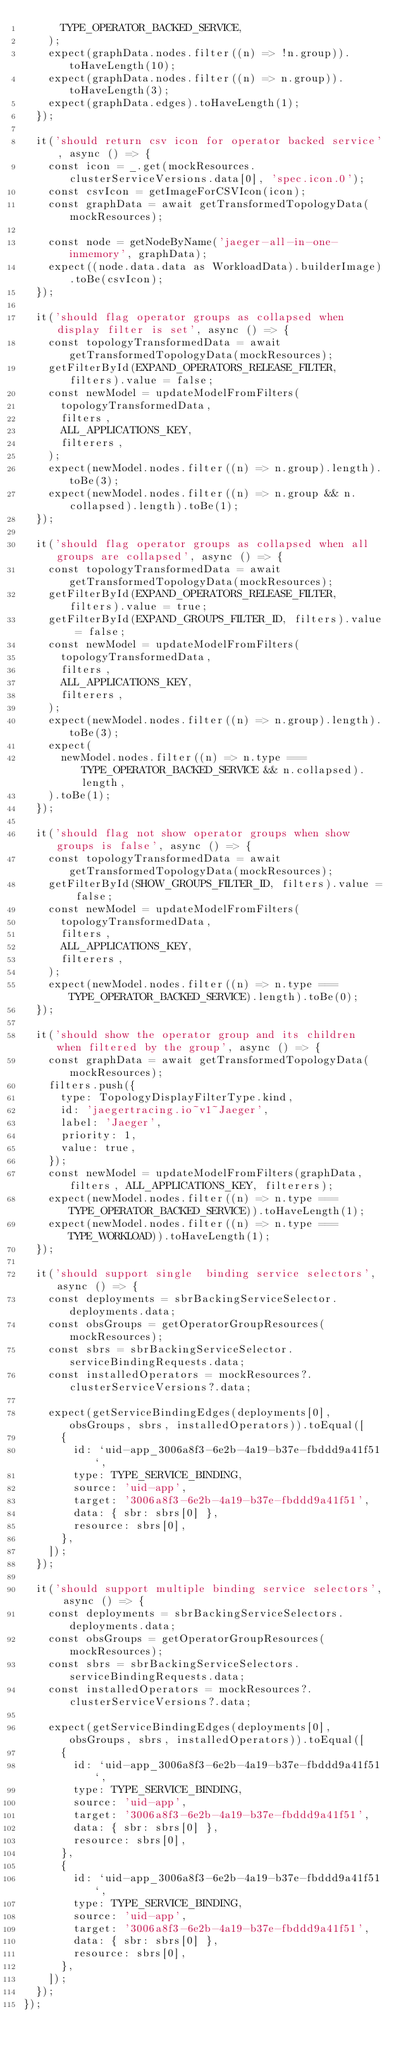Convert code to text. <code><loc_0><loc_0><loc_500><loc_500><_TypeScript_>      TYPE_OPERATOR_BACKED_SERVICE,
    );
    expect(graphData.nodes.filter((n) => !n.group)).toHaveLength(10);
    expect(graphData.nodes.filter((n) => n.group)).toHaveLength(3);
    expect(graphData.edges).toHaveLength(1);
  });

  it('should return csv icon for operator backed service', async () => {
    const icon = _.get(mockResources.clusterServiceVersions.data[0], 'spec.icon.0');
    const csvIcon = getImageForCSVIcon(icon);
    const graphData = await getTransformedTopologyData(mockResources);

    const node = getNodeByName('jaeger-all-in-one-inmemory', graphData);
    expect((node.data.data as WorkloadData).builderImage).toBe(csvIcon);
  });

  it('should flag operator groups as collapsed when display filter is set', async () => {
    const topologyTransformedData = await getTransformedTopologyData(mockResources);
    getFilterById(EXPAND_OPERATORS_RELEASE_FILTER, filters).value = false;
    const newModel = updateModelFromFilters(
      topologyTransformedData,
      filters,
      ALL_APPLICATIONS_KEY,
      filterers,
    );
    expect(newModel.nodes.filter((n) => n.group).length).toBe(3);
    expect(newModel.nodes.filter((n) => n.group && n.collapsed).length).toBe(1);
  });

  it('should flag operator groups as collapsed when all groups are collapsed', async () => {
    const topologyTransformedData = await getTransformedTopologyData(mockResources);
    getFilterById(EXPAND_OPERATORS_RELEASE_FILTER, filters).value = true;
    getFilterById(EXPAND_GROUPS_FILTER_ID, filters).value = false;
    const newModel = updateModelFromFilters(
      topologyTransformedData,
      filters,
      ALL_APPLICATIONS_KEY,
      filterers,
    );
    expect(newModel.nodes.filter((n) => n.group).length).toBe(3);
    expect(
      newModel.nodes.filter((n) => n.type === TYPE_OPERATOR_BACKED_SERVICE && n.collapsed).length,
    ).toBe(1);
  });

  it('should flag not show operator groups when show groups is false', async () => {
    const topologyTransformedData = await getTransformedTopologyData(mockResources);
    getFilterById(SHOW_GROUPS_FILTER_ID, filters).value = false;
    const newModel = updateModelFromFilters(
      topologyTransformedData,
      filters,
      ALL_APPLICATIONS_KEY,
      filterers,
    );
    expect(newModel.nodes.filter((n) => n.type === TYPE_OPERATOR_BACKED_SERVICE).length).toBe(0);
  });

  it('should show the operator group and its children when filtered by the group', async () => {
    const graphData = await getTransformedTopologyData(mockResources);
    filters.push({
      type: TopologyDisplayFilterType.kind,
      id: 'jaegertracing.io~v1~Jaeger',
      label: 'Jaeger',
      priority: 1,
      value: true,
    });
    const newModel = updateModelFromFilters(graphData, filters, ALL_APPLICATIONS_KEY, filterers);
    expect(newModel.nodes.filter((n) => n.type === TYPE_OPERATOR_BACKED_SERVICE)).toHaveLength(1);
    expect(newModel.nodes.filter((n) => n.type === TYPE_WORKLOAD)).toHaveLength(1);
  });

  it('should support single  binding service selectors', async () => {
    const deployments = sbrBackingServiceSelector.deployments.data;
    const obsGroups = getOperatorGroupResources(mockResources);
    const sbrs = sbrBackingServiceSelector.serviceBindingRequests.data;
    const installedOperators = mockResources?.clusterServiceVersions?.data;

    expect(getServiceBindingEdges(deployments[0], obsGroups, sbrs, installedOperators)).toEqual([
      {
        id: `uid-app_3006a8f3-6e2b-4a19-b37e-fbddd9a41f51`,
        type: TYPE_SERVICE_BINDING,
        source: 'uid-app',
        target: '3006a8f3-6e2b-4a19-b37e-fbddd9a41f51',
        data: { sbr: sbrs[0] },
        resource: sbrs[0],
      },
    ]);
  });

  it('should support multiple binding service selectors', async () => {
    const deployments = sbrBackingServiceSelectors.deployments.data;
    const obsGroups = getOperatorGroupResources(mockResources);
    const sbrs = sbrBackingServiceSelectors.serviceBindingRequests.data;
    const installedOperators = mockResources?.clusterServiceVersions?.data;

    expect(getServiceBindingEdges(deployments[0], obsGroups, sbrs, installedOperators)).toEqual([
      {
        id: `uid-app_3006a8f3-6e2b-4a19-b37e-fbddd9a41f51`,
        type: TYPE_SERVICE_BINDING,
        source: 'uid-app',
        target: '3006a8f3-6e2b-4a19-b37e-fbddd9a41f51',
        data: { sbr: sbrs[0] },
        resource: sbrs[0],
      },
      {
        id: `uid-app_3006a8f3-6e2b-4a19-b37e-fbddd9a41f51`,
        type: TYPE_SERVICE_BINDING,
        source: 'uid-app',
        target: '3006a8f3-6e2b-4a19-b37e-fbddd9a41f51',
        data: { sbr: sbrs[0] },
        resource: sbrs[0],
      },
    ]);
  });
});
</code> 